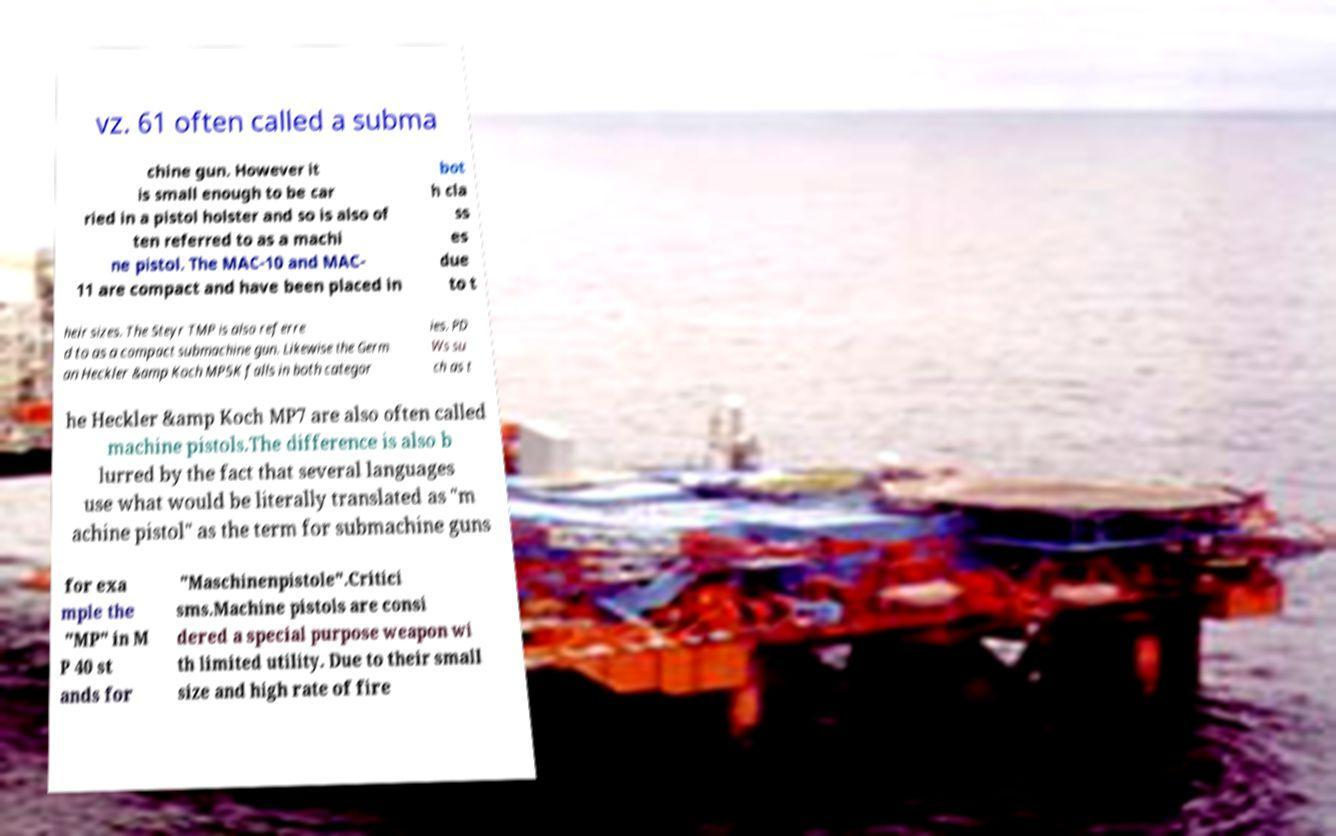Could you assist in decoding the text presented in this image and type it out clearly? vz. 61 often called a subma chine gun. However it is small enough to be car ried in a pistol holster and so is also of ten referred to as a machi ne pistol. The MAC-10 and MAC- 11 are compact and have been placed in bot h cla ss es due to t heir sizes. The Steyr TMP is also referre d to as a compact submachine gun. Likewise the Germ an Heckler &amp Koch MP5K falls in both categor ies. PD Ws su ch as t he Heckler &amp Koch MP7 are also often called machine pistols.The difference is also b lurred by the fact that several languages use what would be literally translated as "m achine pistol" as the term for submachine guns for exa mple the "MP" in M P 40 st ands for "Maschinenpistole".Critici sms.Machine pistols are consi dered a special purpose weapon wi th limited utility. Due to their small size and high rate of fire 